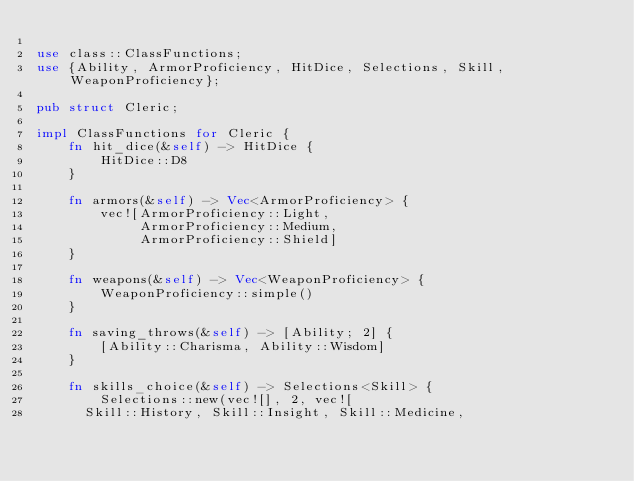<code> <loc_0><loc_0><loc_500><loc_500><_Rust_>
use class::ClassFunctions;
use {Ability, ArmorProficiency, HitDice, Selections, Skill, WeaponProficiency};

pub struct Cleric;

impl ClassFunctions for Cleric {
    fn hit_dice(&self) -> HitDice {
        HitDice::D8
    }

    fn armors(&self) -> Vec<ArmorProficiency> {
        vec![ArmorProficiency::Light,
             ArmorProficiency::Medium,
             ArmorProficiency::Shield]
    }

    fn weapons(&self) -> Vec<WeaponProficiency> {
        WeaponProficiency::simple()
    }

    fn saving_throws(&self) -> [Ability; 2] {
        [Ability::Charisma, Ability::Wisdom]
    }

    fn skills_choice(&self) -> Selections<Skill> {
        Selections::new(vec![], 2, vec![
			Skill::History, Skill::Insight, Skill::Medicine,</code> 